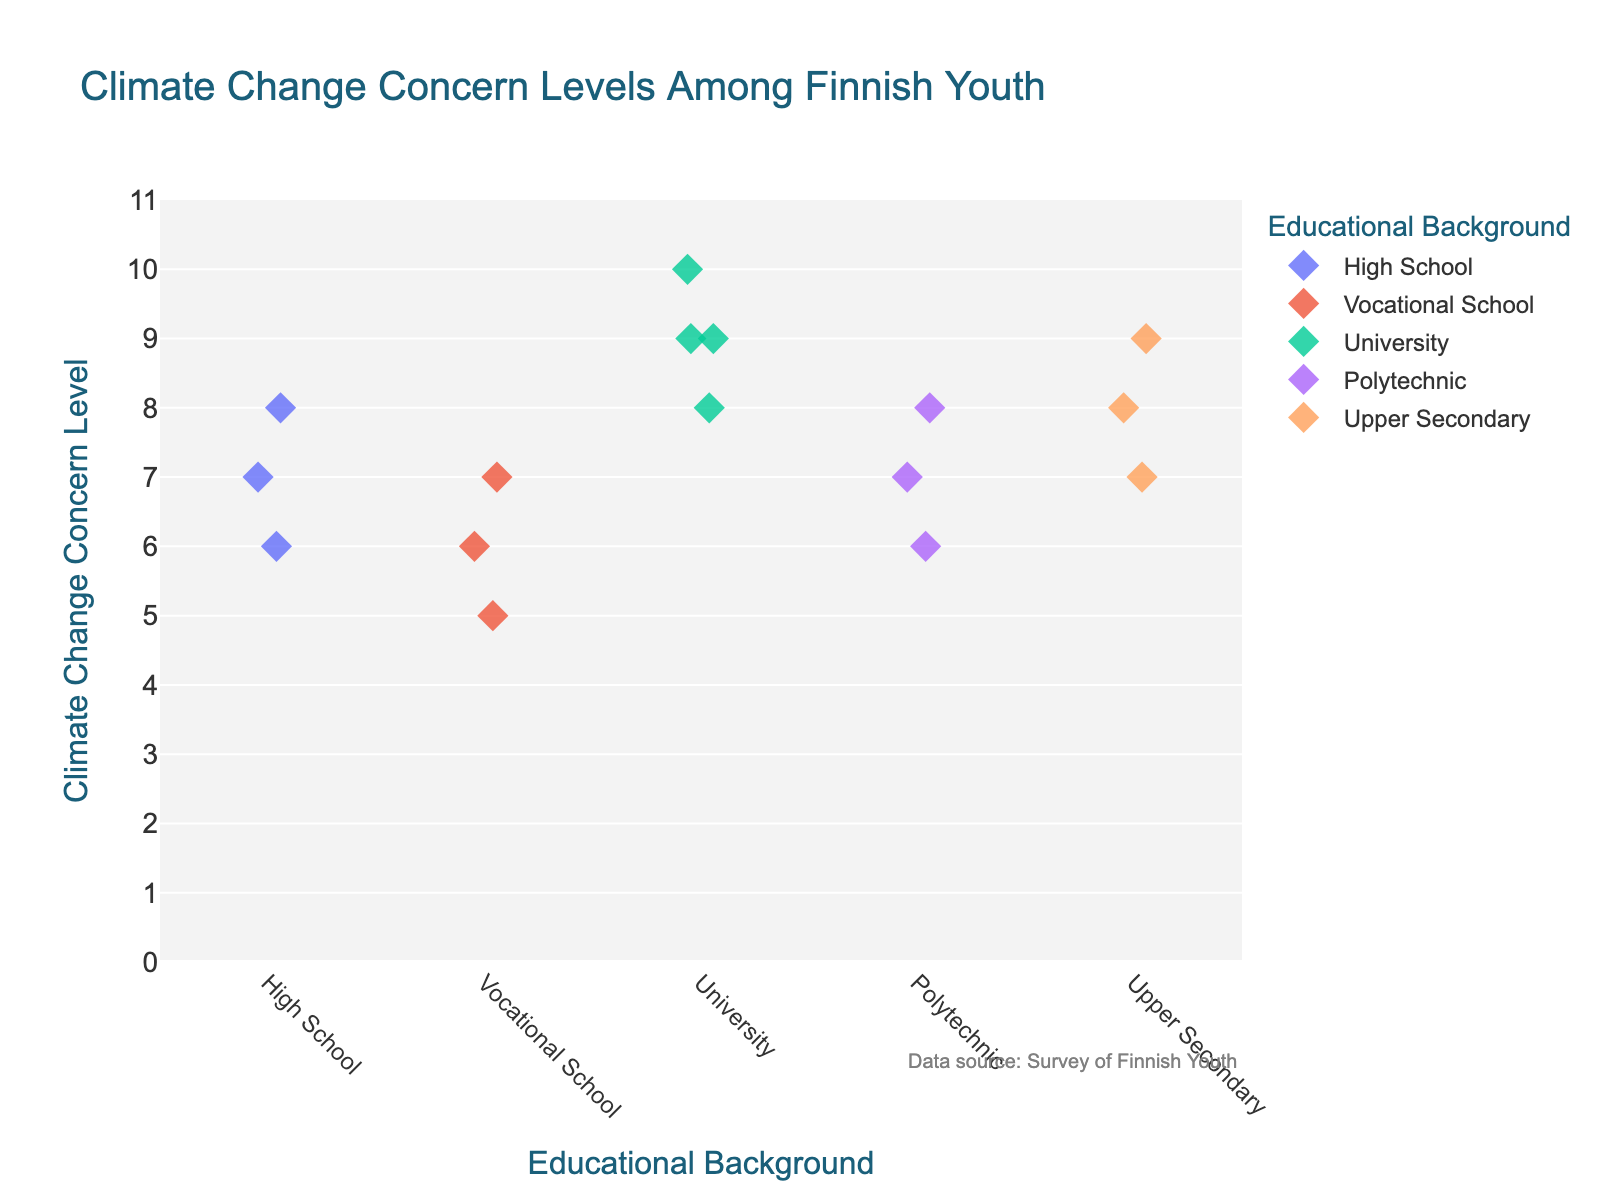What's the title of the figure? The title of the figure is displayed at the top, which usually gives a summary of the chart's subject matter.
Answer: Climate Change Concern Levels Among Finnish Youth What educational background shows the highest levels of climate change concern? Look at the range of values on the y-axis for each educational background category and identify which has the highest points.
Answer: University How many data points are there for the 'Polytechnic' category? Count the number of diamond markers corresponding to the 'Polytechnic' category.
Answer: 3 What's the average climate change concern level among those with a High School background? Add the concern levels (7 + 6 + 8) and divide by the number of data points (3).
Answer: 7 Which category has the lowest climate change concern level? Identify the lowest point on the y-axis across all categories. The lowest concern level is for Vocational School at 5.
Answer: Vocational School Are there any educational backgrounds with the same highest concern level? Look for the highest climate change concern levels and see if multiple categories share this level. Both University and Upper Secondary have concern levels of 9.
Answer: Yes, University and Upper Secondary What's the minimum and maximum concern level shown by Upper Secondary students? Look at the range of values on the y-axis for the 'Upper Secondary' category. The lowest value is 7, and the highest is 9.
Answer: 7 (min), 9 (max) Which educational background shows the most diverse range of concern levels? Determine which category has the largest spread between its highest and lowest values.
Answer: Vocational School Compare the median concern levels between University and High School students. Order the data points for each category and find the value in the middle. For University: (8, 9, 9, 10) – the median is 9. For High School: (6, 7, 8) – the median is 7.
Answer: University median: 9, High School median: 7 What's the overall trend in concern levels across different educational backgrounds? Observe whether concern levels generally increase, decrease, or remain about the same across categories.
Answer: Higher educational backgrounds tend to show higher concern levels 